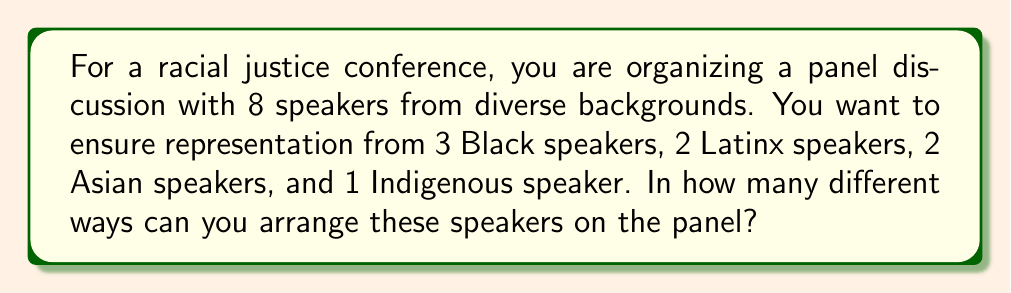Help me with this question. Let's approach this step-by-step:

1) This is a permutation problem. We need to arrange 8 people in a specific order.

2) However, we need to consider that there are multiple speakers from some backgrounds. This means we have repeated elements in our permutation.

3) The formula for permutations with repeated elements is:

   $$\frac{n!}{n_1! \cdot n_2! \cdot ... \cdot n_k!}$$

   Where $n$ is the total number of elements, and $n_1, n_2, ..., n_k$ are the numbers of each repeated element.

4) In our case:
   - Total speakers (n) = 8
   - Black speakers (n_1) = 3
   - Latinx speakers (n_2) = 2
   - Asian speakers (n_3) = 2
   - Indigenous speaker (n_4) = 1

5) Plugging these into our formula:

   $$\frac{8!}{3! \cdot 2! \cdot 2! \cdot 1!}$$

6) Let's calculate this:
   $$\frac{8 \cdot 7 \cdot 6 \cdot 5 \cdot 4 \cdot 3 \cdot 2 \cdot 1}{(3 \cdot 2 \cdot 1) \cdot (2 \cdot 1) \cdot (2 \cdot 1) \cdot 1}$$

   $$\frac{40,320}{12 \cdot 2 \cdot 2 \cdot 1} = \frac{40,320}{48} = 840$$

Therefore, there are 840 different ways to arrange the speakers on the panel.
Answer: 840 